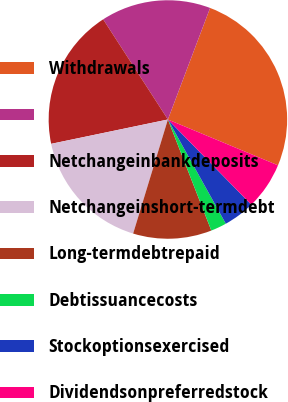Convert chart to OTSL. <chart><loc_0><loc_0><loc_500><loc_500><pie_chart><fcel>Withdrawals<fcel>Unnamed: 1<fcel>Netchangeinbankdeposits<fcel>Netchangeinshort-termdebt<fcel>Long-termdebtrepaid<fcel>Debtissuancecosts<fcel>Stockoptionsexercised<fcel>Dividendsonpreferredstock<nl><fcel>25.52%<fcel>14.89%<fcel>19.14%<fcel>17.02%<fcel>10.64%<fcel>2.14%<fcel>4.26%<fcel>6.39%<nl></chart> 